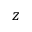<formula> <loc_0><loc_0><loc_500><loc_500>z</formula> 